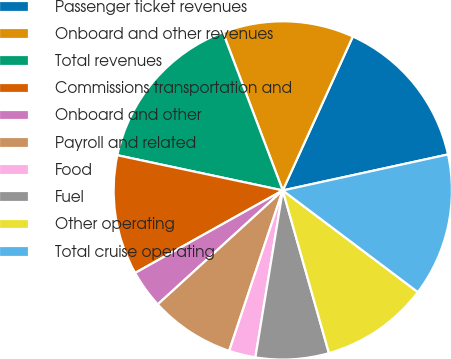Convert chart to OTSL. <chart><loc_0><loc_0><loc_500><loc_500><pie_chart><fcel>Passenger ticket revenues<fcel>Onboard and other revenues<fcel>Total revenues<fcel>Commissions transportation and<fcel>Onboard and other<fcel>Payroll and related<fcel>Food<fcel>Fuel<fcel>Other operating<fcel>Total cruise operating<nl><fcel>14.79%<fcel>12.56%<fcel>15.9%<fcel>11.45%<fcel>3.65%<fcel>8.11%<fcel>2.54%<fcel>6.99%<fcel>10.33%<fcel>13.68%<nl></chart> 